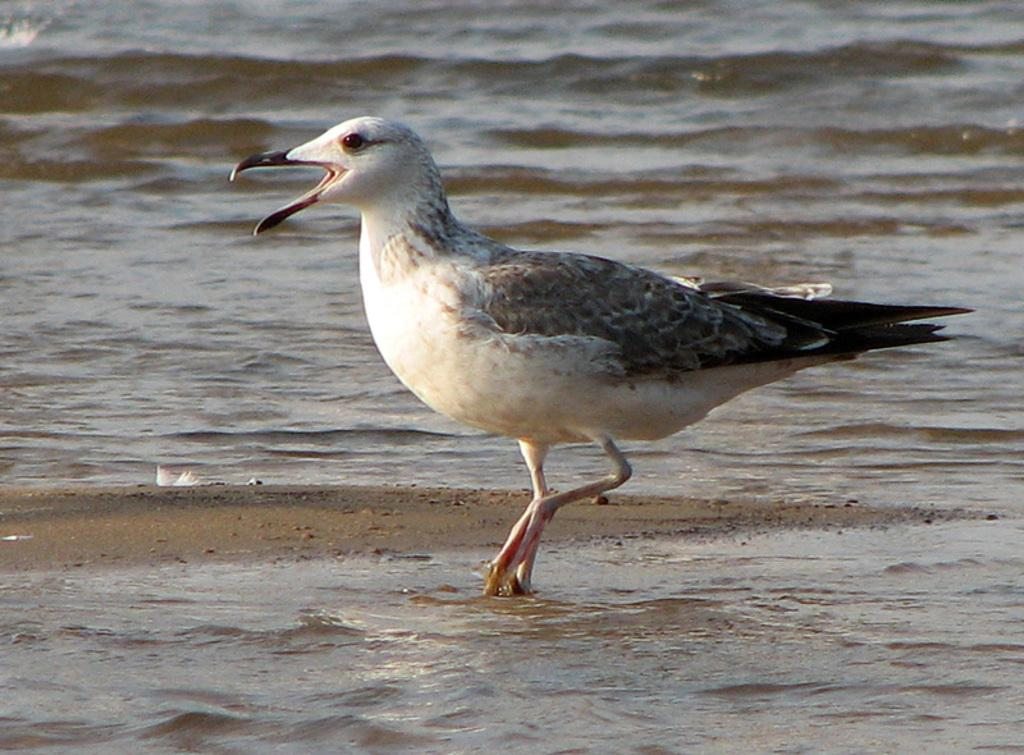What type of animal can be seen in the picture? There is a bird in the picture. Where is the bird located in the image? The bird is standing on the water. What is the primary element visible in the image? Water is visible in the image. What time of day is it in the image, considering the presence of a goose? There is no goose present in the image, and therefore we cannot determine the time of day based on its presence. 